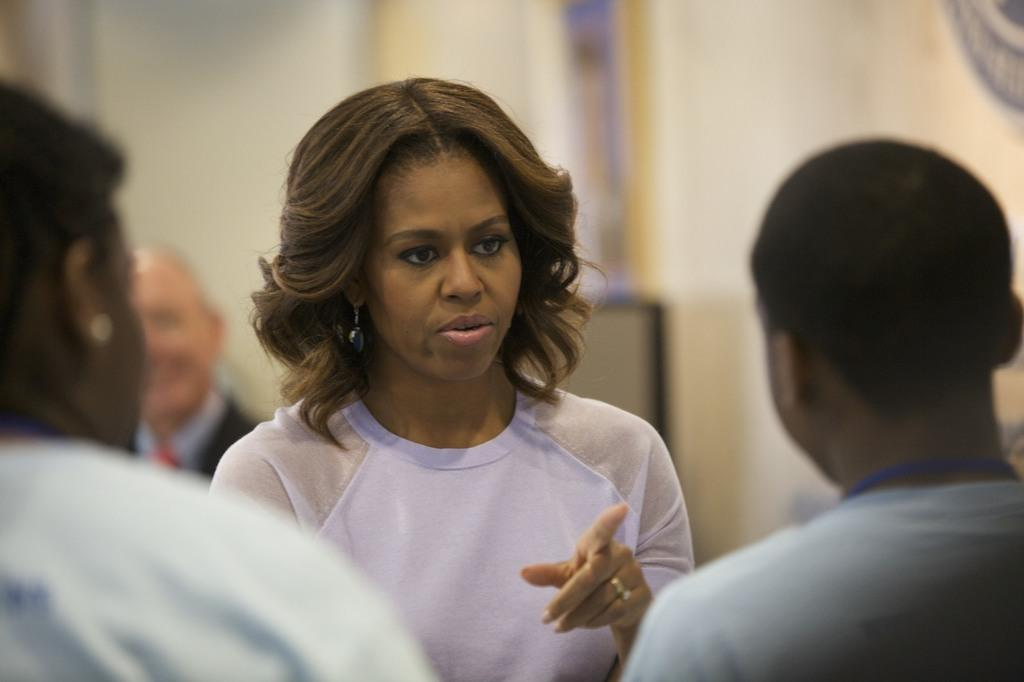Who is the main subject in the image? There is a woman in the middle of the image. What is the woman doing in the image? The woman is speaking. What is the woman wearing in the image? The woman is wearing a white top. How many other people are present in the image? There are two persons on either side of the woman. What type of voyage is the woman embarking on in the image? There is no indication of a voyage in the image; the woman is simply speaking. How does the woman shake hands with the person on her left in the image? There is no handshake depicted in the image; the woman is speaking and not engaging in any physical contact with the other people. 